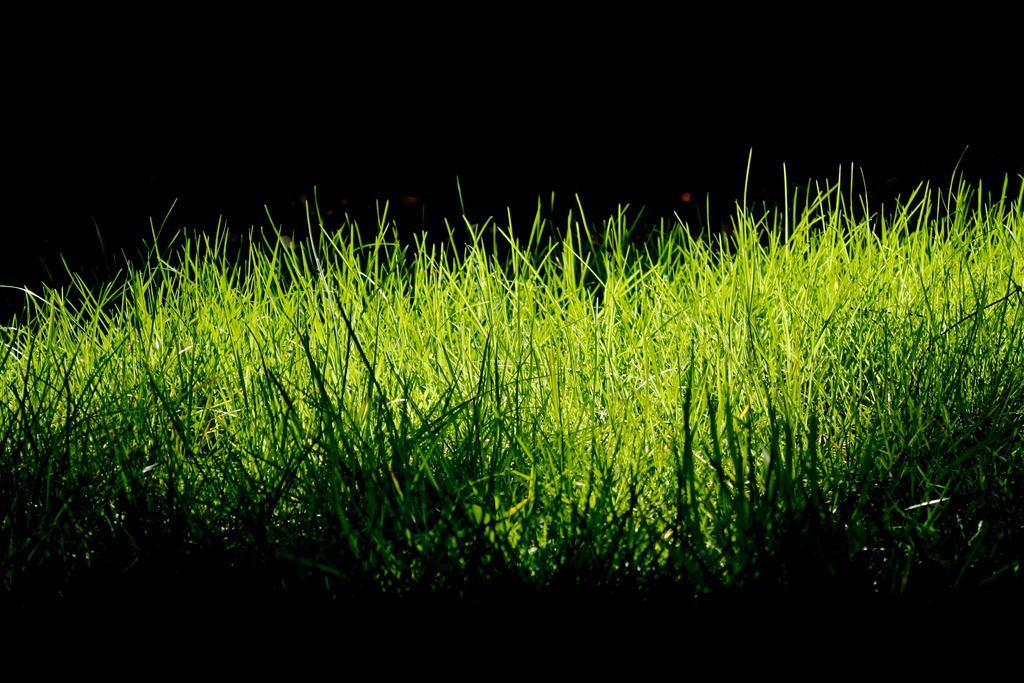Can you describe this image briefly? In this image we can see grass. 